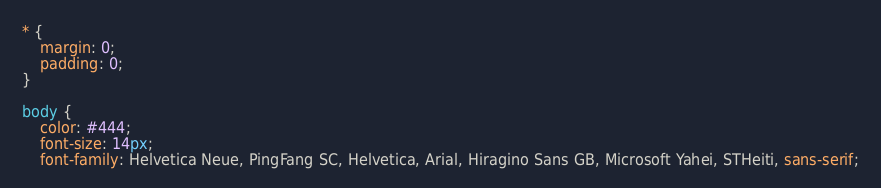Convert code to text. <code><loc_0><loc_0><loc_500><loc_500><_CSS_>* {
    margin: 0;
    padding: 0;
}

body {
    color: #444;
    font-size: 14px;
    font-family: Helvetica Neue, PingFang SC, Helvetica, Arial, Hiragino Sans GB, Microsoft Yahei, STHeiti, sans-serif;</code> 